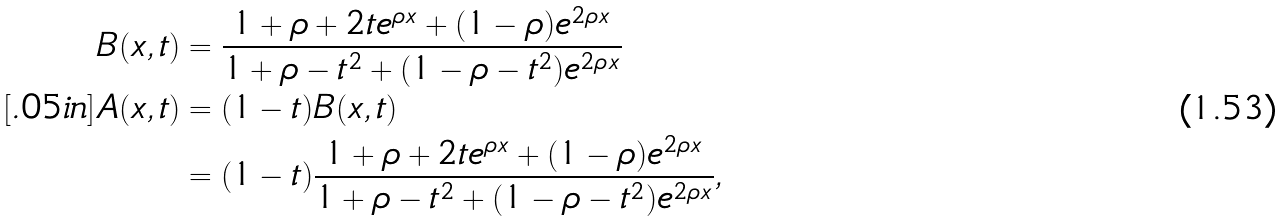Convert formula to latex. <formula><loc_0><loc_0><loc_500><loc_500>B ( x , t ) & = \frac { 1 + \rho + 2 t e ^ { \rho x } + ( 1 - \rho ) e ^ { 2 \rho x } } { 1 + \rho - t ^ { 2 } + ( 1 - \rho - t ^ { 2 } ) e ^ { 2 \rho x } } \\ [ . 0 5 i n ] A ( x , t ) & = ( 1 - t ) B ( x , t ) \\ & = ( 1 - t ) \frac { 1 + \rho + 2 t e ^ { \rho x } + ( 1 - \rho ) e ^ { 2 \rho x } } { 1 + \rho - t ^ { 2 } + ( 1 - \rho - t ^ { 2 } ) e ^ { 2 \rho x } } ,</formula> 